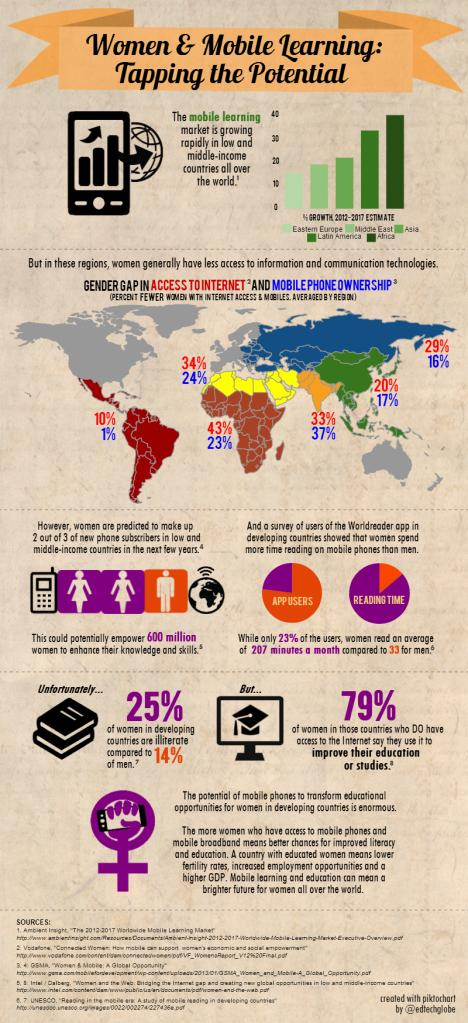Highlight a few significant elements in this photo. Africa has shown the highest growth in mobile learning between 2012 and 2017, according to recent data. In countries with internet facilities, 79% of women use their mobile devices to improve their education. In low and middle-income countries, out of every 3 new phone subscribers, 1 is a man. A significant percentage of women in developing countries are illiterate, with 25% being illiterate. According to recent data, a shocking 14% of men in developing countries are illiterate, which is a concerning issue that needs to be addressed urgently. 